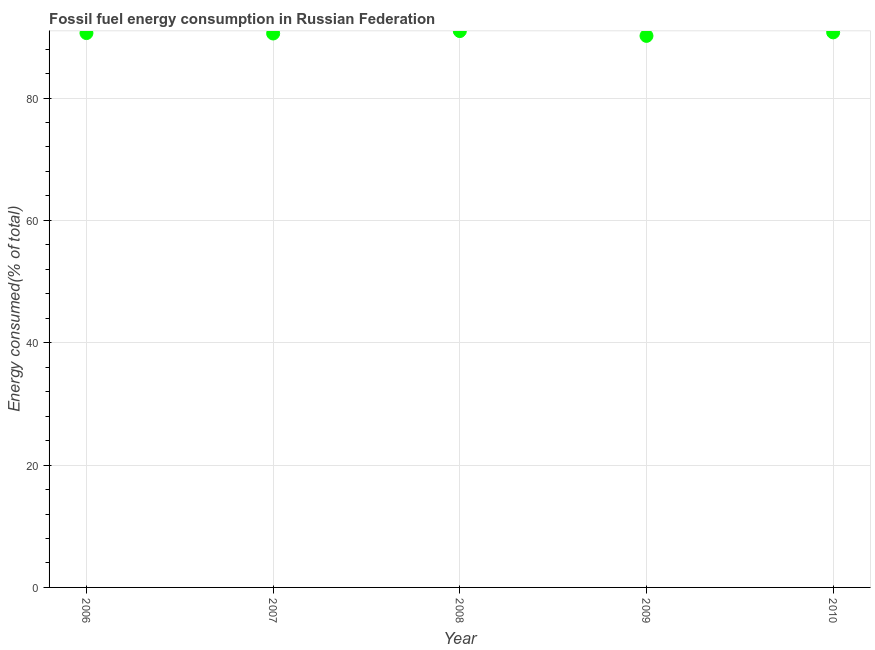What is the fossil fuel energy consumption in 2010?
Keep it short and to the point. 90.73. Across all years, what is the maximum fossil fuel energy consumption?
Your response must be concise. 90.95. Across all years, what is the minimum fossil fuel energy consumption?
Ensure brevity in your answer.  90.16. In which year was the fossil fuel energy consumption maximum?
Keep it short and to the point. 2008. In which year was the fossil fuel energy consumption minimum?
Offer a very short reply. 2009. What is the sum of the fossil fuel energy consumption?
Your answer should be very brief. 453.01. What is the difference between the fossil fuel energy consumption in 2006 and 2010?
Your answer should be compact. -0.11. What is the average fossil fuel energy consumption per year?
Your answer should be very brief. 90.6. What is the median fossil fuel energy consumption?
Provide a succinct answer. 90.62. In how many years, is the fossil fuel energy consumption greater than 20 %?
Make the answer very short. 5. Do a majority of the years between 2010 and 2008 (inclusive) have fossil fuel energy consumption greater than 12 %?
Offer a very short reply. No. What is the ratio of the fossil fuel energy consumption in 2007 to that in 2010?
Give a very brief answer. 1. What is the difference between the highest and the second highest fossil fuel energy consumption?
Keep it short and to the point. 0.21. Is the sum of the fossil fuel energy consumption in 2007 and 2008 greater than the maximum fossil fuel energy consumption across all years?
Your response must be concise. Yes. What is the difference between the highest and the lowest fossil fuel energy consumption?
Your response must be concise. 0.79. Does the fossil fuel energy consumption monotonically increase over the years?
Make the answer very short. No. Does the graph contain grids?
Provide a succinct answer. Yes. What is the title of the graph?
Your response must be concise. Fossil fuel energy consumption in Russian Federation. What is the label or title of the X-axis?
Keep it short and to the point. Year. What is the label or title of the Y-axis?
Provide a short and direct response. Energy consumed(% of total). What is the Energy consumed(% of total) in 2006?
Offer a very short reply. 90.62. What is the Energy consumed(% of total) in 2007?
Keep it short and to the point. 90.55. What is the Energy consumed(% of total) in 2008?
Offer a very short reply. 90.95. What is the Energy consumed(% of total) in 2009?
Give a very brief answer. 90.16. What is the Energy consumed(% of total) in 2010?
Your response must be concise. 90.73. What is the difference between the Energy consumed(% of total) in 2006 and 2007?
Keep it short and to the point. 0.07. What is the difference between the Energy consumed(% of total) in 2006 and 2008?
Offer a terse response. -0.33. What is the difference between the Energy consumed(% of total) in 2006 and 2009?
Your answer should be very brief. 0.46. What is the difference between the Energy consumed(% of total) in 2006 and 2010?
Offer a very short reply. -0.11. What is the difference between the Energy consumed(% of total) in 2007 and 2008?
Provide a succinct answer. -0.4. What is the difference between the Energy consumed(% of total) in 2007 and 2009?
Give a very brief answer. 0.39. What is the difference between the Energy consumed(% of total) in 2007 and 2010?
Ensure brevity in your answer.  -0.18. What is the difference between the Energy consumed(% of total) in 2008 and 2009?
Keep it short and to the point. 0.79. What is the difference between the Energy consumed(% of total) in 2008 and 2010?
Your answer should be compact. 0.21. What is the difference between the Energy consumed(% of total) in 2009 and 2010?
Your answer should be compact. -0.57. What is the ratio of the Energy consumed(% of total) in 2006 to that in 2007?
Keep it short and to the point. 1. What is the ratio of the Energy consumed(% of total) in 2006 to that in 2010?
Ensure brevity in your answer.  1. What is the ratio of the Energy consumed(% of total) in 2008 to that in 2009?
Ensure brevity in your answer.  1.01. What is the ratio of the Energy consumed(% of total) in 2009 to that in 2010?
Ensure brevity in your answer.  0.99. 